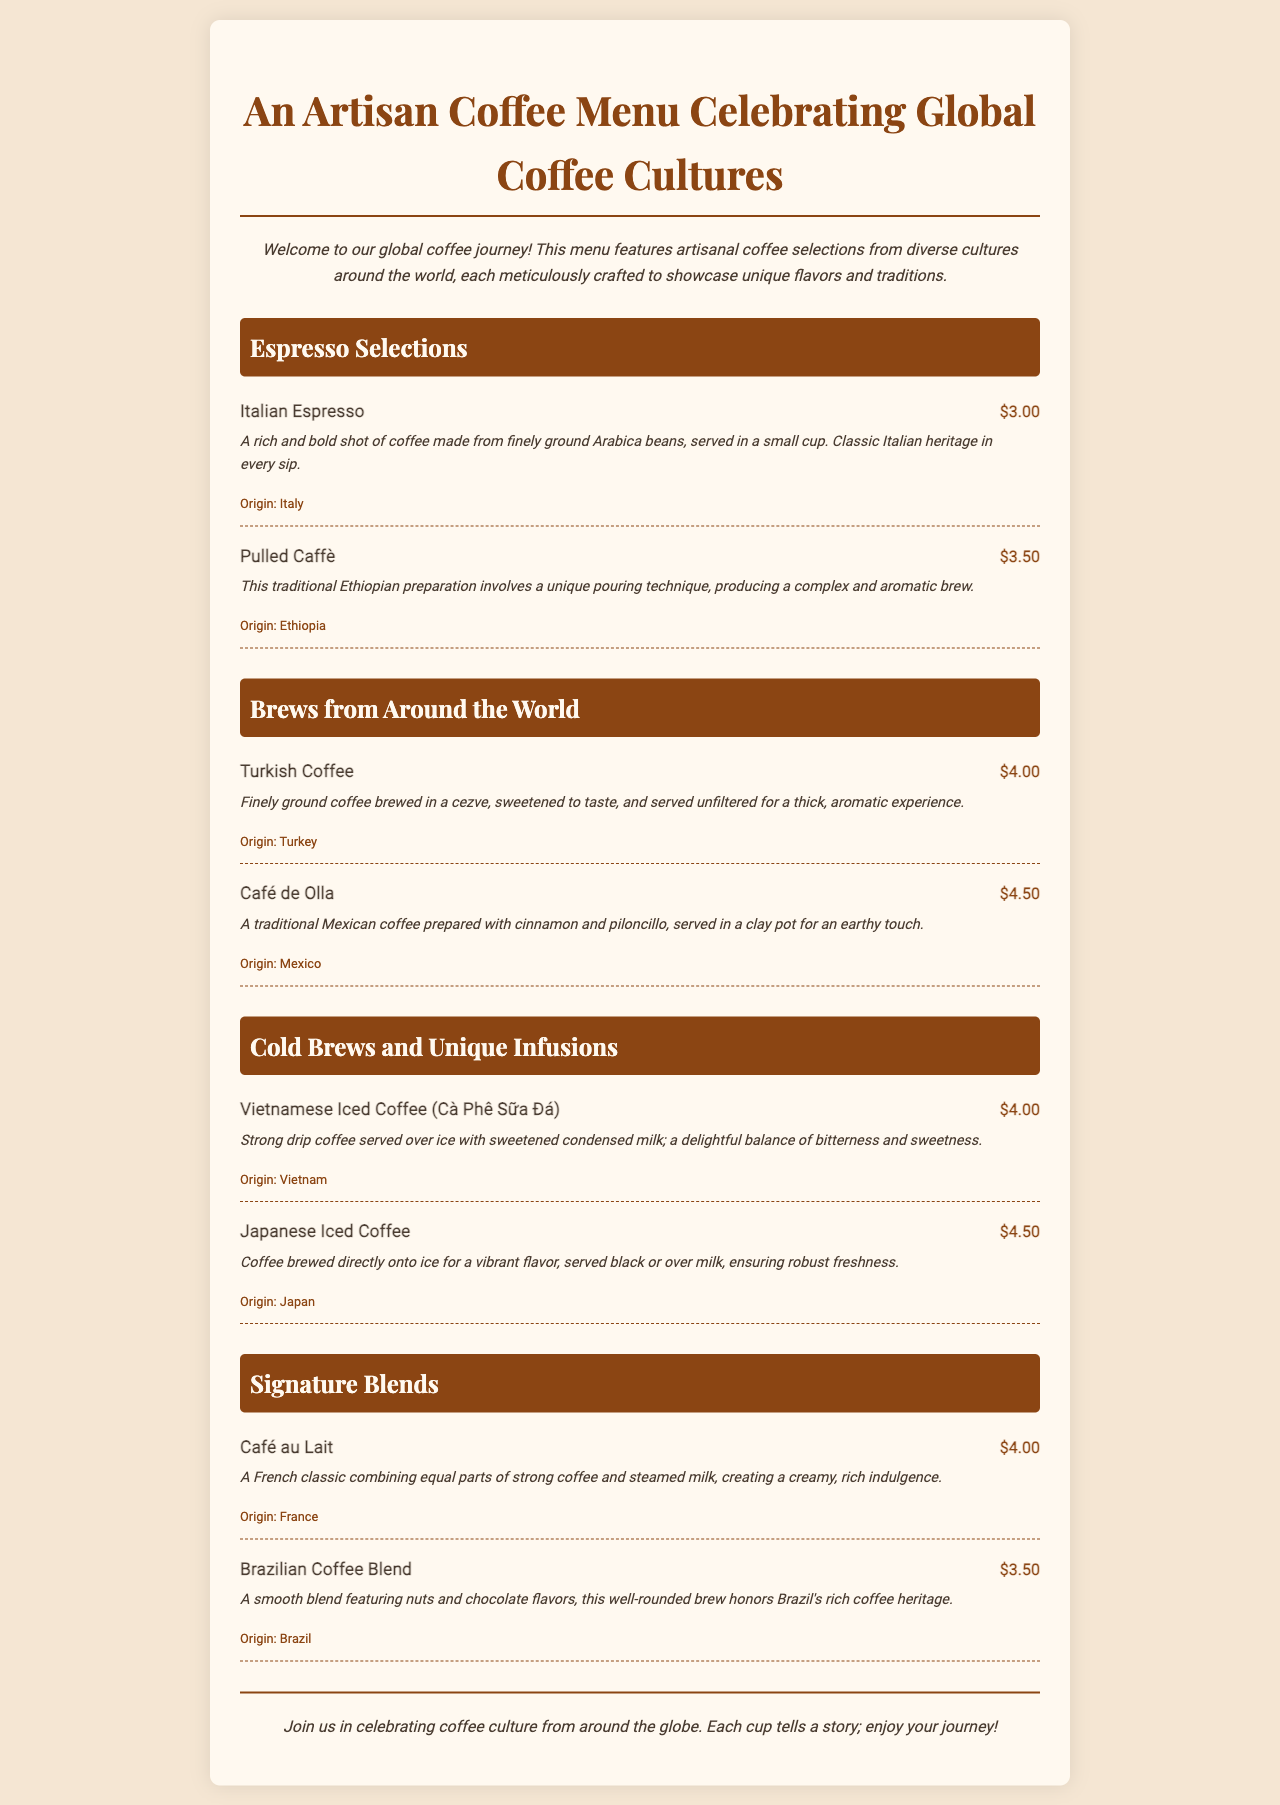What is the title of the menu? The title of the menu is prominently displayed at the top of the document, indicating its theme and content.
Answer: An Artisan Coffee Menu Celebrating Global Coffee Cultures How many espresso selections are listed? The document includes two sections related to espresso selections, counting the items listed beneath that section.
Answer: 2 What is the price of Turkish Coffee? The price is shown next to the menu item for Turkish Coffee, providing specific pricing information.
Answer: $4.00 Which country is associated with Café de Olla? This information can be found in the item description where each coffee is linked to its country of origin.
Answer: Mexico What is the description of Vietnamese Iced Coffee? The menu provides specific descriptions of each item, indicating the preparation and taste experience.
Answer: Strong drip coffee served over ice with sweetened condensed milk; a delightful balance of bitterness and sweetness How much does the Brazilian Coffee Blend cost compared to Italian Espresso? This question requires comparing the prices of both items listed in the document.
Answer: $3.50 vs. $3.00 What is unique about the preparation of Pulled Caffè? The document provides specific preparation techniques that make certain coffees unique, emphasizing cultural methods.
Answer: Unique pouring technique What type of beverage is Café au Lait? The description of Café au Lait indicates its ingredient composition, defining the drink type clearly.
Answer: A French classic combining equal parts of strong coffee and steamed milk What cultural significance does the menu emphasize? The introduction of the menu highlights the overarching theme and focus on coffee cultures originating from different parts of the world.
Answer: Celebrating coffee culture from around the globe 